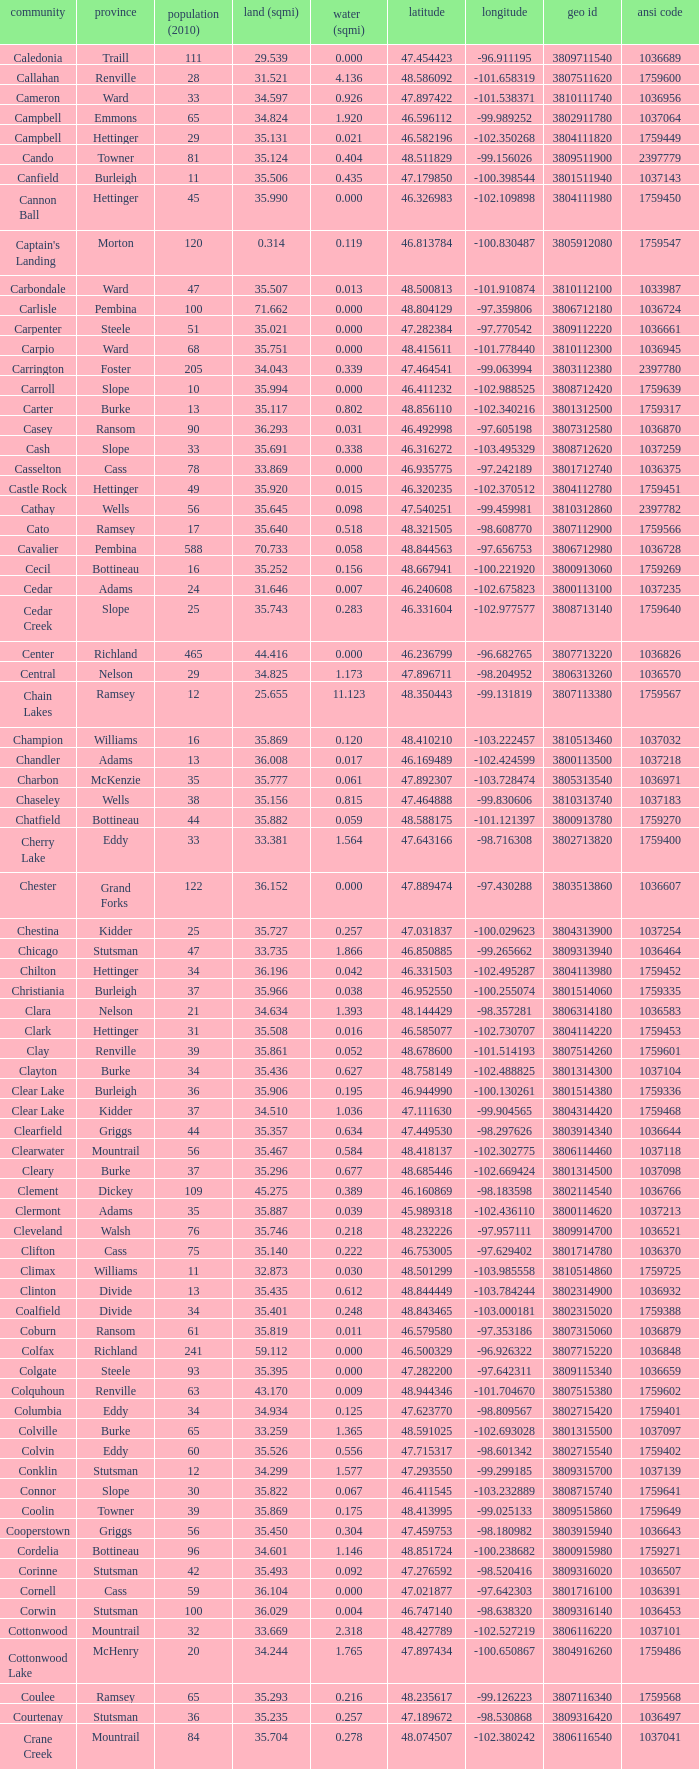What was the latitude of the Clearwater townsship? 48.418137. 